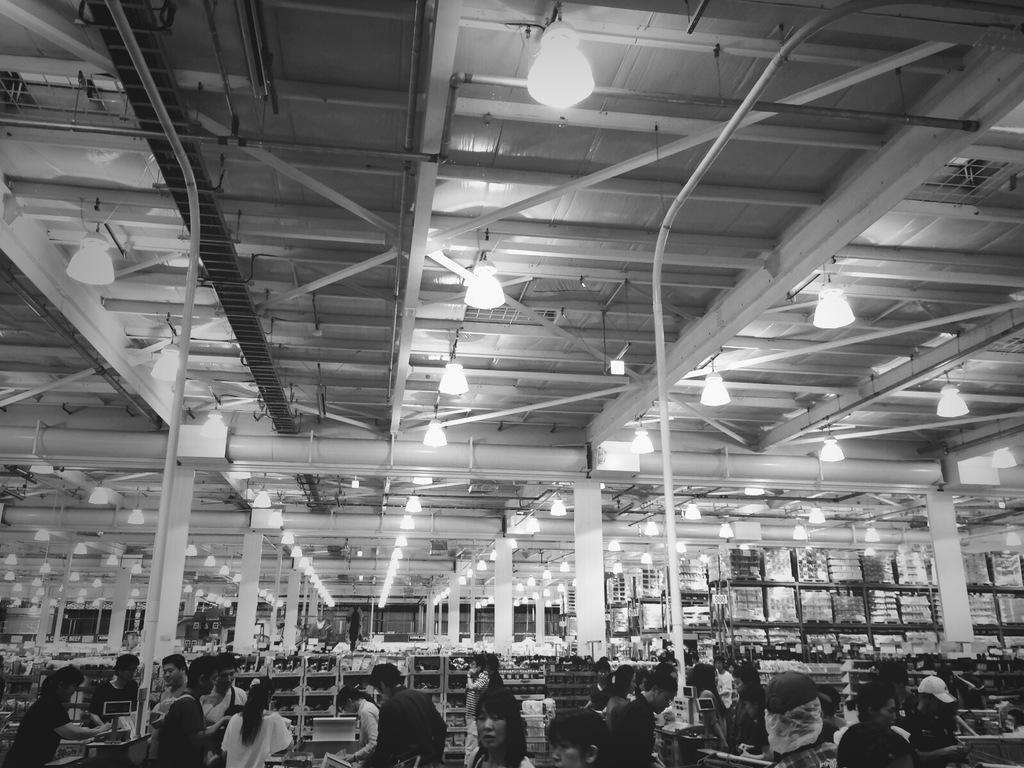What is the color scheme of the image? The image is black and white. What type of establishment is depicted in the image? The image shows a store. What can be found on the shelves in the store? There are shelves with products in the store. What are the rods used for in the store? The purpose of the rods in the store is not specified in the facts provided. How is the store illuminated? There are lights attached to the ceiling in the store. Can you see a squirrel climbing the shelves in the store? There is no squirrel present in the image; it depicts a store with people and products. Is there a picture of a friend hanging on the wall in the store? The facts provided do not mention any pictures or friends in the store, only shelves with products and lights attached to the ceiling. 